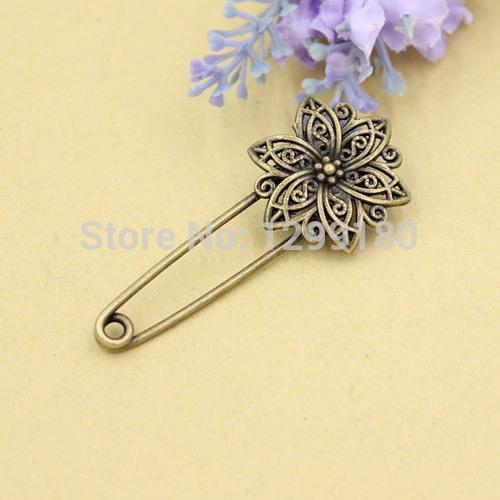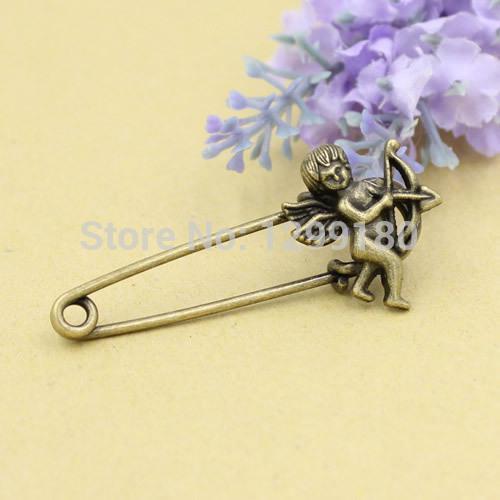The first image is the image on the left, the second image is the image on the right. For the images shown, is this caption "There is an animal on one of the clips." true? Answer yes or no. No. 